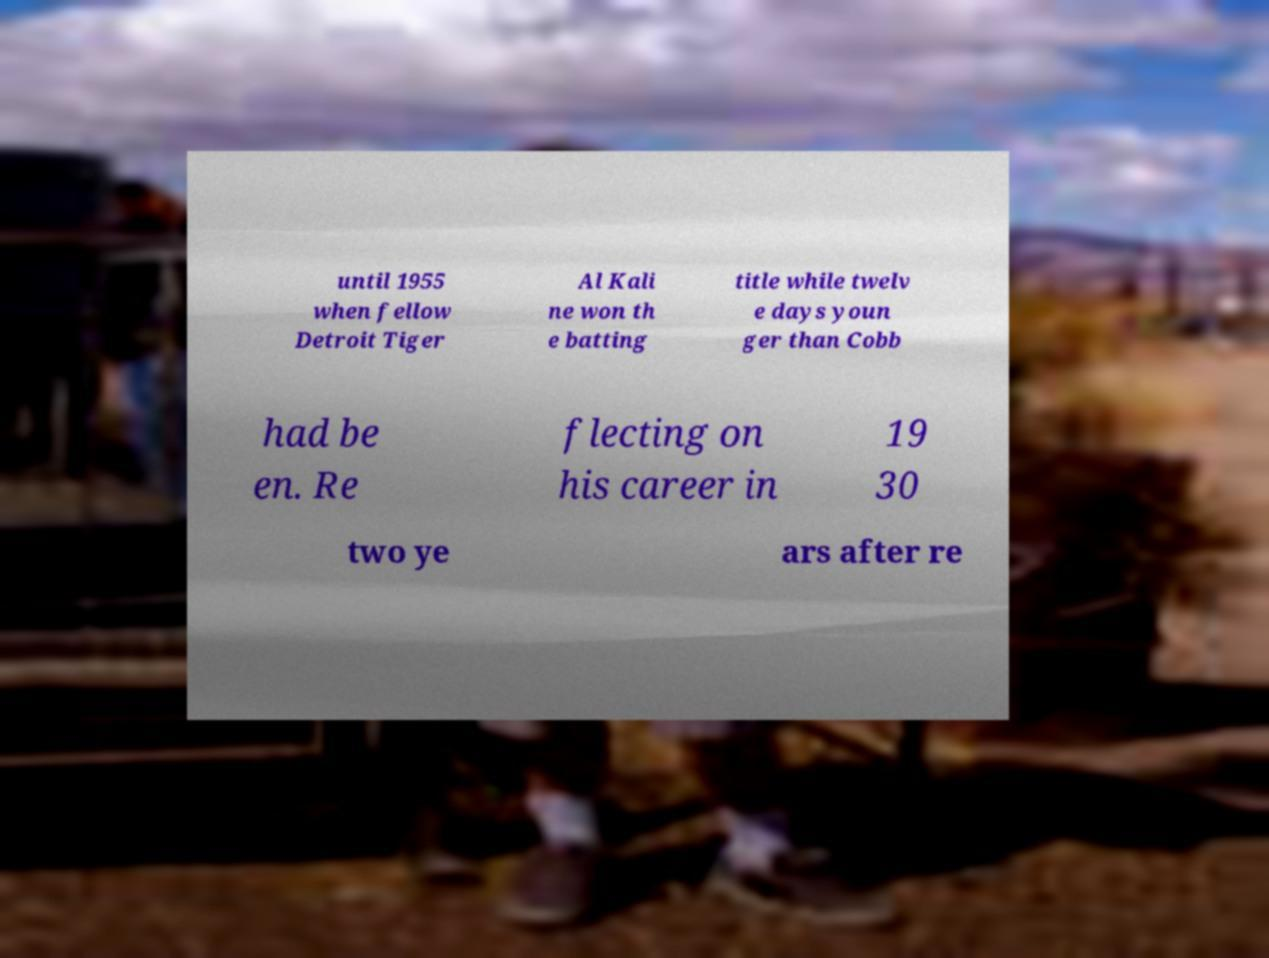Could you extract and type out the text from this image? until 1955 when fellow Detroit Tiger Al Kali ne won th e batting title while twelv e days youn ger than Cobb had be en. Re flecting on his career in 19 30 two ye ars after re 